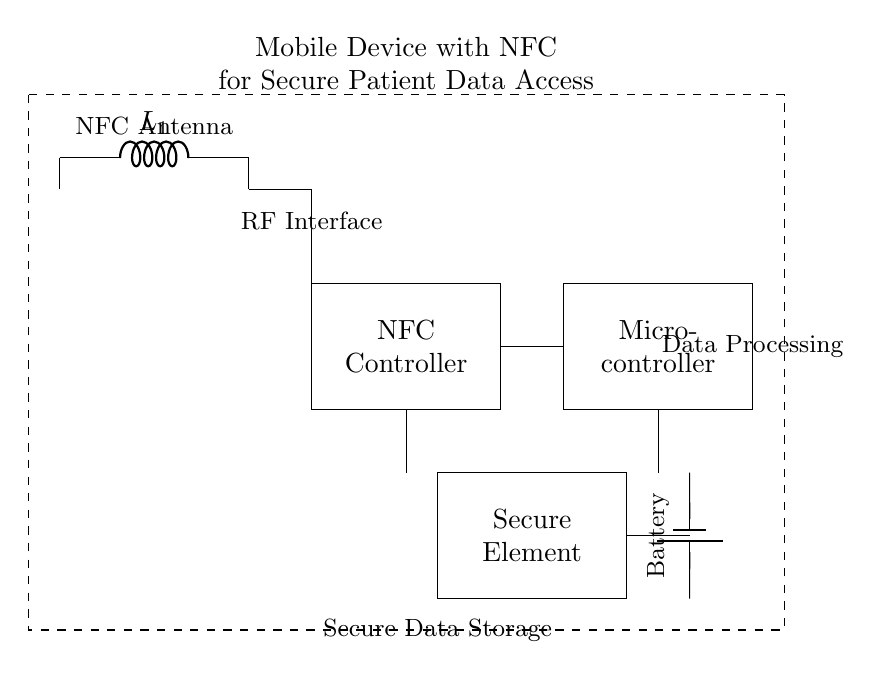What is the primary function of the NFC antenna? The NFC antenna is used to facilitate wireless communication between mobile devices and NFC-enabled readers, enabling secure data transfer.
Answer: Wireless communication What component is used for secure data storage? The secure element is specifically designed for storing sensitive data securely in the mobile device.
Answer: Secure element How many components connect directly to the NFC controller? There are two components that connect directly to the NFC controller: the NFC antenna and the microcontroller.
Answer: Two components What does the battery supply to the circuit? The battery supplies power to the microcontroller and the secure element, ensuring the circuit operates effectively.
Answer: Power What is the role of the microcontroller in this circuit? The microcontroller processes data acquired from the NFC controller and manages communication with the secure element for data access.
Answer: Data processing What type of device is represented in the circuit diagram? The circuit diagram represents a mobile device designed to use NFC technology for secure access to patient data.
Answer: Mobile device with NFC 